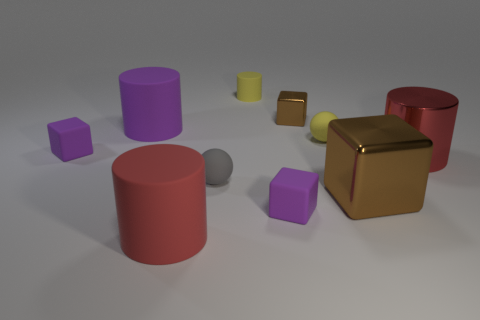Subtract all tiny blocks. How many blocks are left? 1 Subtract 2 cylinders. How many cylinders are left? 2 Subtract all purple cylinders. How many cylinders are left? 3 Subtract all cyan cylinders. Subtract all green cubes. How many cylinders are left? 4 Subtract all balls. How many objects are left? 8 Add 3 red matte objects. How many red matte objects exist? 4 Subtract 1 red cylinders. How many objects are left? 9 Subtract all tiny red shiny cubes. Subtract all big red cylinders. How many objects are left? 8 Add 1 brown things. How many brown things are left? 3 